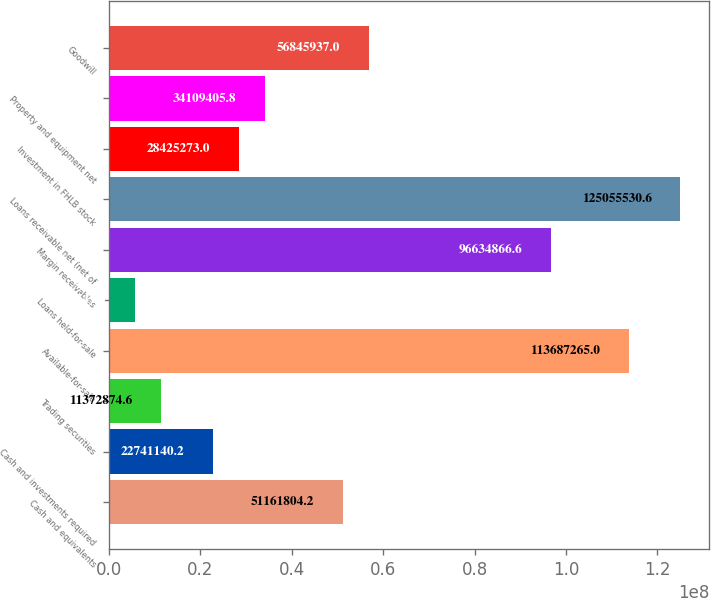Convert chart. <chart><loc_0><loc_0><loc_500><loc_500><bar_chart><fcel>Cash and equivalents<fcel>Cash and investments required<fcel>Trading securities<fcel>Available-for-sale<fcel>Loans held-for-sale<fcel>Margin receivables<fcel>Loans receivable net (net of<fcel>Investment in FHLB stock<fcel>Property and equipment net<fcel>Goodwill<nl><fcel>5.11618e+07<fcel>2.27411e+07<fcel>1.13729e+07<fcel>1.13687e+08<fcel>5.68874e+06<fcel>9.66349e+07<fcel>1.25056e+08<fcel>2.84253e+07<fcel>3.41094e+07<fcel>5.68459e+07<nl></chart> 